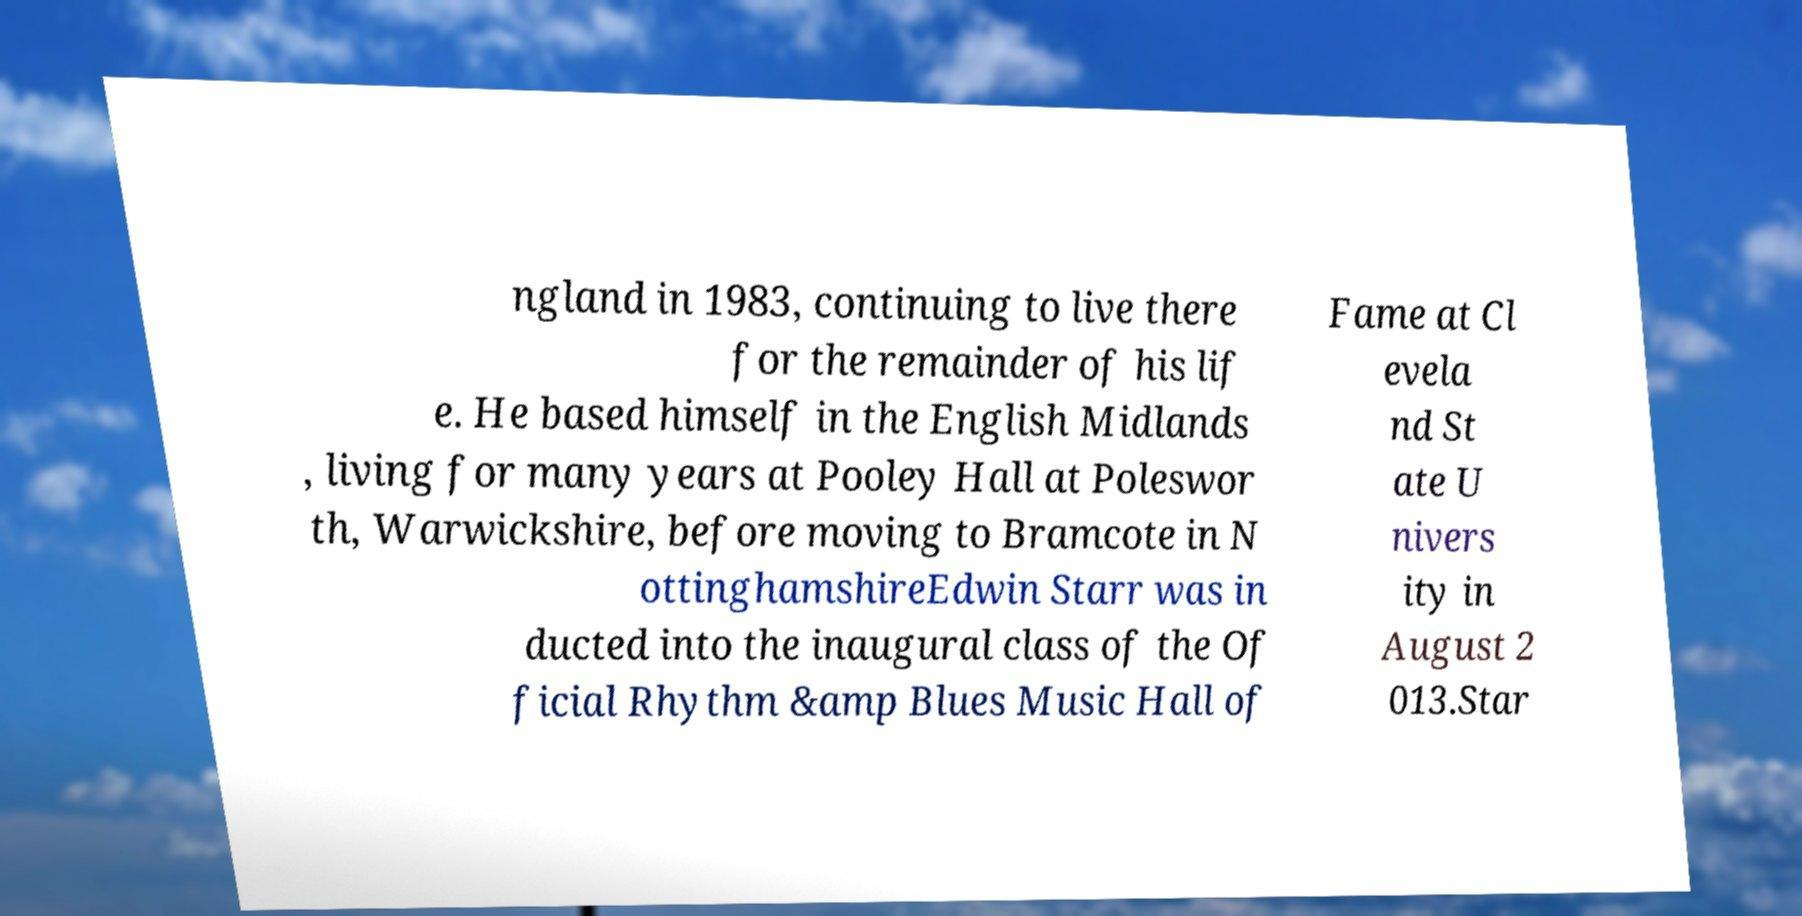Can you read and provide the text displayed in the image?This photo seems to have some interesting text. Can you extract and type it out for me? ngland in 1983, continuing to live there for the remainder of his lif e. He based himself in the English Midlands , living for many years at Pooley Hall at Poleswor th, Warwickshire, before moving to Bramcote in N ottinghamshireEdwin Starr was in ducted into the inaugural class of the Of ficial Rhythm &amp Blues Music Hall of Fame at Cl evela nd St ate U nivers ity in August 2 013.Star 